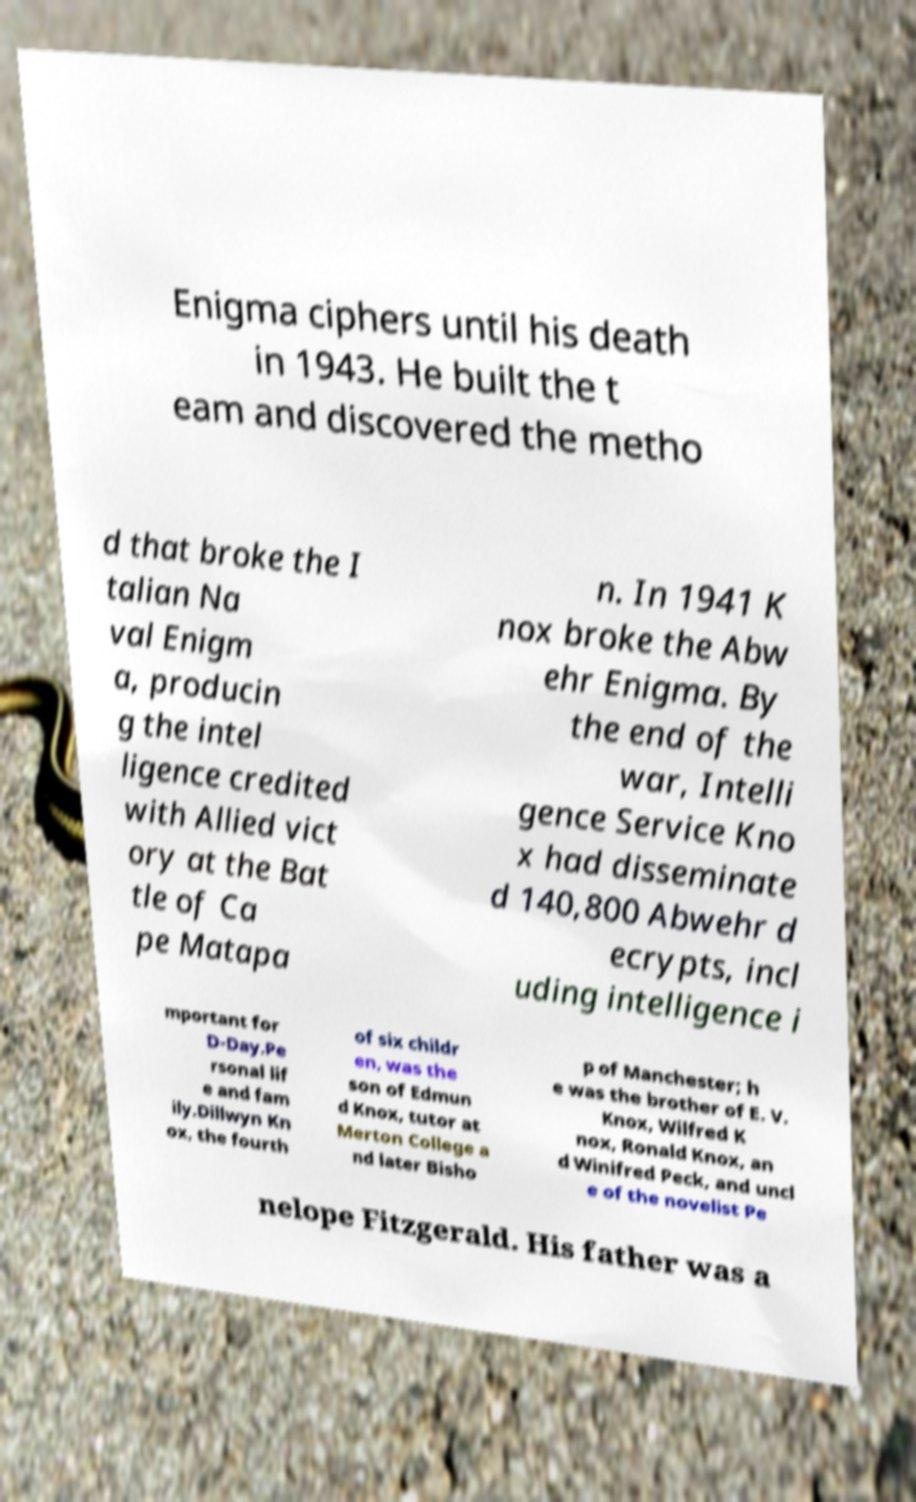Could you assist in decoding the text presented in this image and type it out clearly? Enigma ciphers until his death in 1943. He built the t eam and discovered the metho d that broke the I talian Na val Enigm a, producin g the intel ligence credited with Allied vict ory at the Bat tle of Ca pe Matapa n. In 1941 K nox broke the Abw ehr Enigma. By the end of the war, Intelli gence Service Kno x had disseminate d 140,800 Abwehr d ecrypts, incl uding intelligence i mportant for D-Day.Pe rsonal lif e and fam ily.Dillwyn Kn ox, the fourth of six childr en, was the son of Edmun d Knox, tutor at Merton College a nd later Bisho p of Manchester; h e was the brother of E. V. Knox, Wilfred K nox, Ronald Knox, an d Winifred Peck, and uncl e of the novelist Pe nelope Fitzgerald. His father was a 